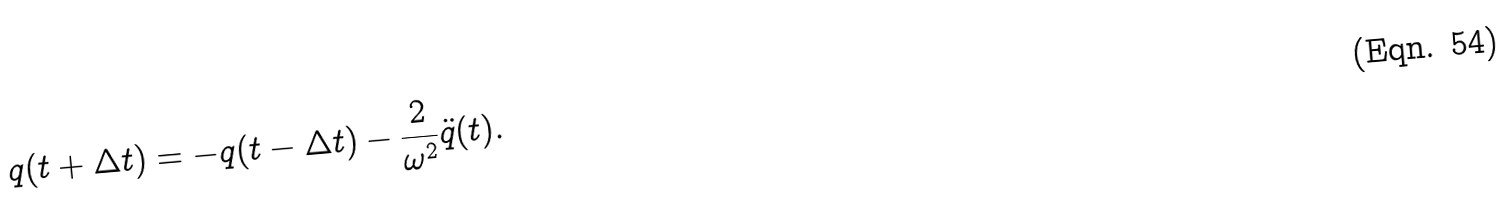<formula> <loc_0><loc_0><loc_500><loc_500>q ( t + \Delta t ) = - q ( t - \Delta t ) - \frac { 2 } { \omega ^ { 2 } } \ddot { q } ( t ) .</formula> 